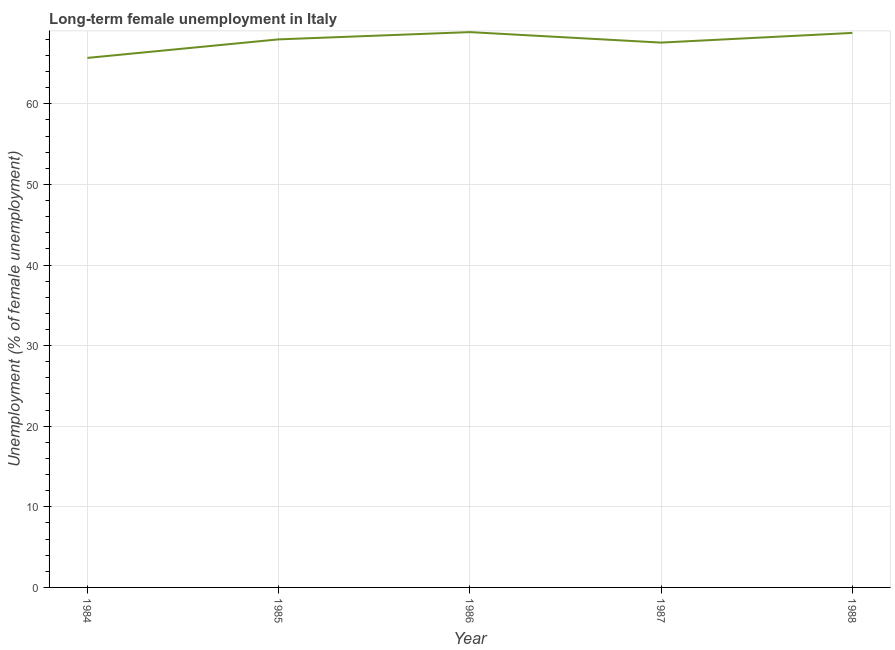What is the long-term female unemployment in 1986?
Offer a very short reply. 68.9. Across all years, what is the maximum long-term female unemployment?
Your response must be concise. 68.9. Across all years, what is the minimum long-term female unemployment?
Your response must be concise. 65.7. In which year was the long-term female unemployment maximum?
Provide a short and direct response. 1986. In which year was the long-term female unemployment minimum?
Give a very brief answer. 1984. What is the sum of the long-term female unemployment?
Provide a succinct answer. 339. What is the difference between the long-term female unemployment in 1986 and 1987?
Provide a short and direct response. 1.3. What is the average long-term female unemployment per year?
Provide a short and direct response. 67.8. What is the median long-term female unemployment?
Your answer should be very brief. 68. Do a majority of the years between 1984 and 1988 (inclusive) have long-term female unemployment greater than 26 %?
Offer a very short reply. Yes. What is the ratio of the long-term female unemployment in 1984 to that in 1986?
Provide a short and direct response. 0.95. What is the difference between the highest and the second highest long-term female unemployment?
Keep it short and to the point. 0.1. What is the difference between the highest and the lowest long-term female unemployment?
Your answer should be very brief. 3.2. In how many years, is the long-term female unemployment greater than the average long-term female unemployment taken over all years?
Your answer should be very brief. 3. Does the long-term female unemployment monotonically increase over the years?
Ensure brevity in your answer.  No. Are the values on the major ticks of Y-axis written in scientific E-notation?
Offer a terse response. No. Does the graph contain any zero values?
Make the answer very short. No. What is the title of the graph?
Offer a terse response. Long-term female unemployment in Italy. What is the label or title of the Y-axis?
Offer a very short reply. Unemployment (% of female unemployment). What is the Unemployment (% of female unemployment) of 1984?
Keep it short and to the point. 65.7. What is the Unemployment (% of female unemployment) in 1986?
Provide a short and direct response. 68.9. What is the Unemployment (% of female unemployment) of 1987?
Your answer should be very brief. 67.6. What is the Unemployment (% of female unemployment) in 1988?
Ensure brevity in your answer.  68.8. What is the difference between the Unemployment (% of female unemployment) in 1984 and 1985?
Offer a terse response. -2.3. What is the difference between the Unemployment (% of female unemployment) in 1984 and 1986?
Keep it short and to the point. -3.2. What is the difference between the Unemployment (% of female unemployment) in 1984 and 1987?
Provide a short and direct response. -1.9. What is the difference between the Unemployment (% of female unemployment) in 1984 and 1988?
Offer a terse response. -3.1. What is the difference between the Unemployment (% of female unemployment) in 1985 and 1986?
Your response must be concise. -0.9. What is the difference between the Unemployment (% of female unemployment) in 1985 and 1987?
Your answer should be compact. 0.4. What is the difference between the Unemployment (% of female unemployment) in 1985 and 1988?
Your answer should be compact. -0.8. What is the difference between the Unemployment (% of female unemployment) in 1986 and 1987?
Give a very brief answer. 1.3. What is the difference between the Unemployment (% of female unemployment) in 1986 and 1988?
Provide a succinct answer. 0.1. What is the ratio of the Unemployment (% of female unemployment) in 1984 to that in 1985?
Provide a short and direct response. 0.97. What is the ratio of the Unemployment (% of female unemployment) in 1984 to that in 1986?
Your answer should be very brief. 0.95. What is the ratio of the Unemployment (% of female unemployment) in 1984 to that in 1988?
Provide a succinct answer. 0.95. What is the ratio of the Unemployment (% of female unemployment) in 1985 to that in 1988?
Your answer should be compact. 0.99. What is the ratio of the Unemployment (% of female unemployment) in 1986 to that in 1987?
Provide a succinct answer. 1.02. 